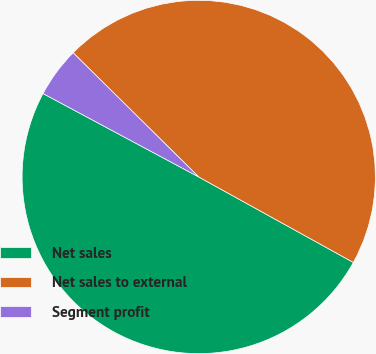Convert chart. <chart><loc_0><loc_0><loc_500><loc_500><pie_chart><fcel>Net sales<fcel>Net sales to external<fcel>Segment profit<nl><fcel>49.79%<fcel>45.63%<fcel>4.58%<nl></chart> 